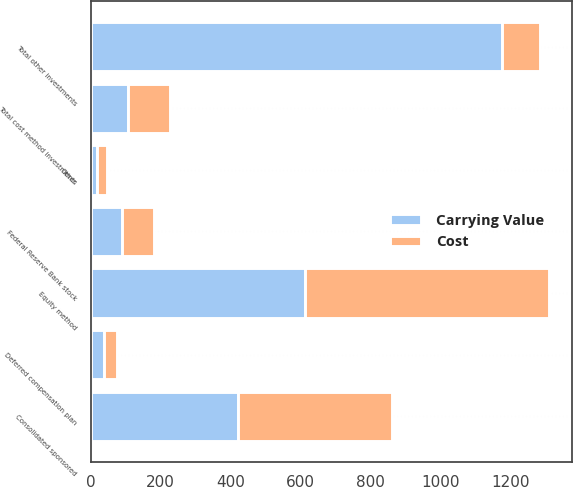Convert chart to OTSL. <chart><loc_0><loc_0><loc_500><loc_500><stacked_bar_chart><ecel><fcel>Consolidated sponsored<fcel>Equity method<fcel>Deferred compensation plan<fcel>Federal Reserve Bank stock<fcel>Other<fcel>Total cost method investments<fcel>Total other investments<nl><fcel>Carrying Value<fcel>420<fcel>613<fcel>37<fcel>90<fcel>17<fcel>107<fcel>1177<nl><fcel>Cost<fcel>441<fcel>697<fcel>39<fcel>90<fcel>29<fcel>119<fcel>107<nl></chart> 